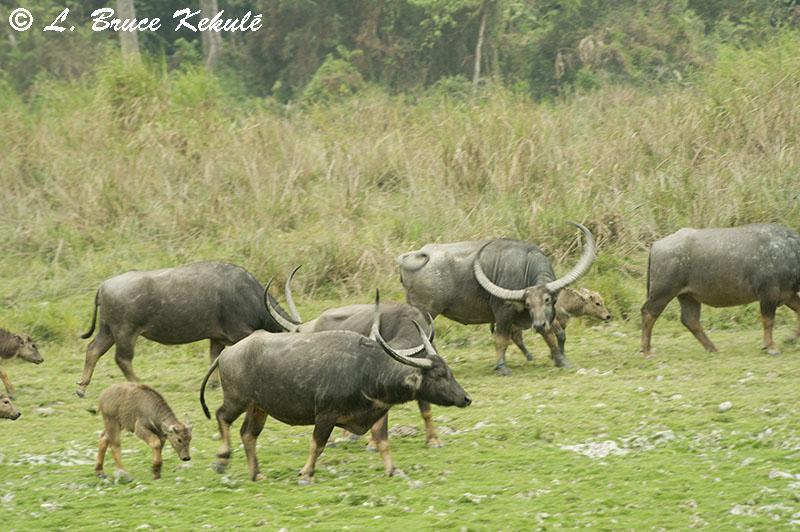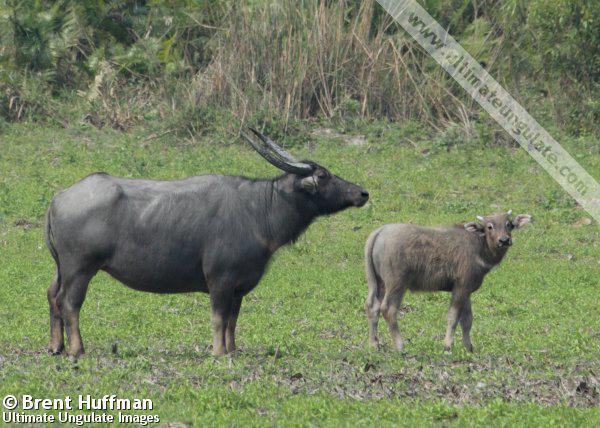The first image is the image on the left, the second image is the image on the right. For the images displayed, is the sentence "An area of water is present in one image of water buffalo." factually correct? Answer yes or no. No. 